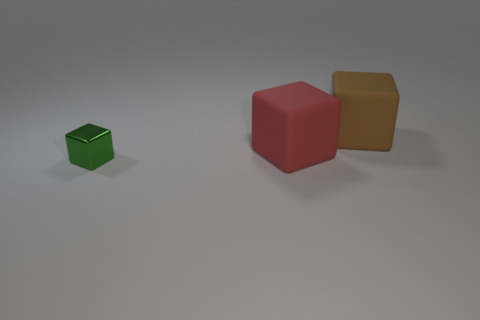There is a matte cube in front of the large thing that is behind the red rubber cube; what size is it?
Ensure brevity in your answer.  Large. How many objects are in front of the large brown matte block and right of the small green metal cube?
Offer a terse response. 1. There is a big object that is right of the big rubber object that is in front of the large brown rubber object; is there a green thing behind it?
Your answer should be very brief. No. There is a brown object that is the same size as the red rubber object; what shape is it?
Make the answer very short. Cube. Is there a large matte block of the same color as the small thing?
Your response must be concise. No. Is the shape of the tiny thing the same as the large red matte object?
Offer a terse response. Yes. What number of big things are either purple things or red rubber cubes?
Your response must be concise. 1. There is a big thing that is made of the same material as the big brown cube; what color is it?
Keep it short and to the point. Red. How many red cubes are the same material as the brown cube?
Give a very brief answer. 1. There is a matte object that is in front of the brown thing; is its size the same as the rubber thing that is behind the large red matte object?
Provide a succinct answer. Yes. 